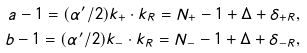Convert formula to latex. <formula><loc_0><loc_0><loc_500><loc_500>a - 1 = ( \alpha ^ { \prime } / 2 ) k _ { + } \cdot k _ { R } = N _ { + } - 1 + \Delta + \delta _ { + R } , \\ b - 1 = ( \alpha ^ { \prime } / 2 ) k _ { - } \cdot k _ { R } = N _ { - } - 1 + \Delta + \delta _ { - R } ,</formula> 